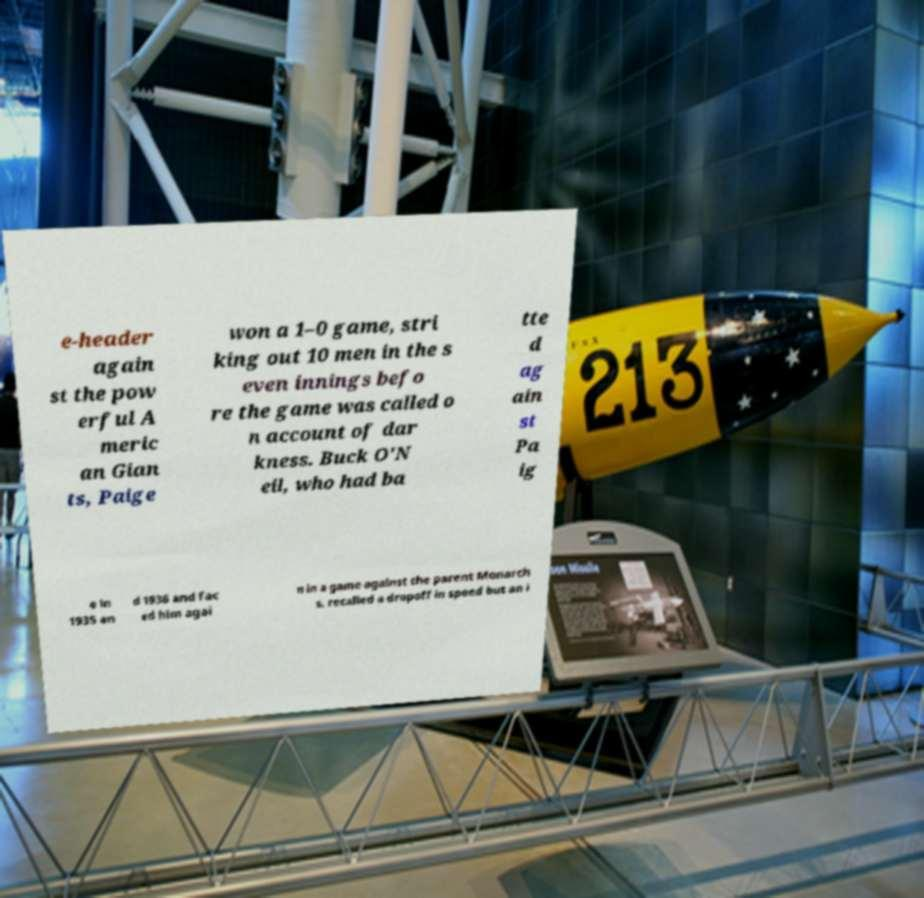There's text embedded in this image that I need extracted. Can you transcribe it verbatim? e-header again st the pow erful A meric an Gian ts, Paige won a 1–0 game, stri king out 10 men in the s even innings befo re the game was called o n account of dar kness. Buck O'N eil, who had ba tte d ag ain st Pa ig e in 1935 an d 1936 and fac ed him agai n in a game against the parent Monarch s, recalled a dropoff in speed but an i 